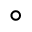Convert formula to latex. <formula><loc_0><loc_0><loc_500><loc_500>^ { \circ }</formula> 